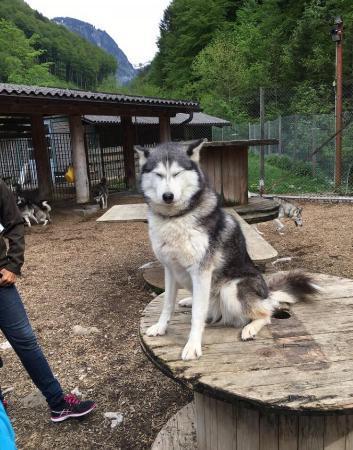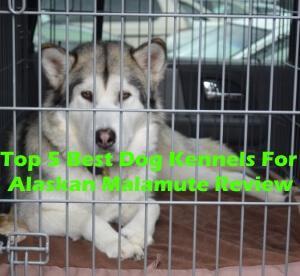The first image is the image on the left, the second image is the image on the right. For the images displayed, is the sentence "One image shows at least one dog in a wire-covered kennel, and the other image shows a dog with 'salt and pepper' coloring on the left of a paler dog." factually correct? Answer yes or no. No. The first image is the image on the left, the second image is the image on the right. Assess this claim about the two images: "At least one dog is standing on grass.". Correct or not? Answer yes or no. No. 